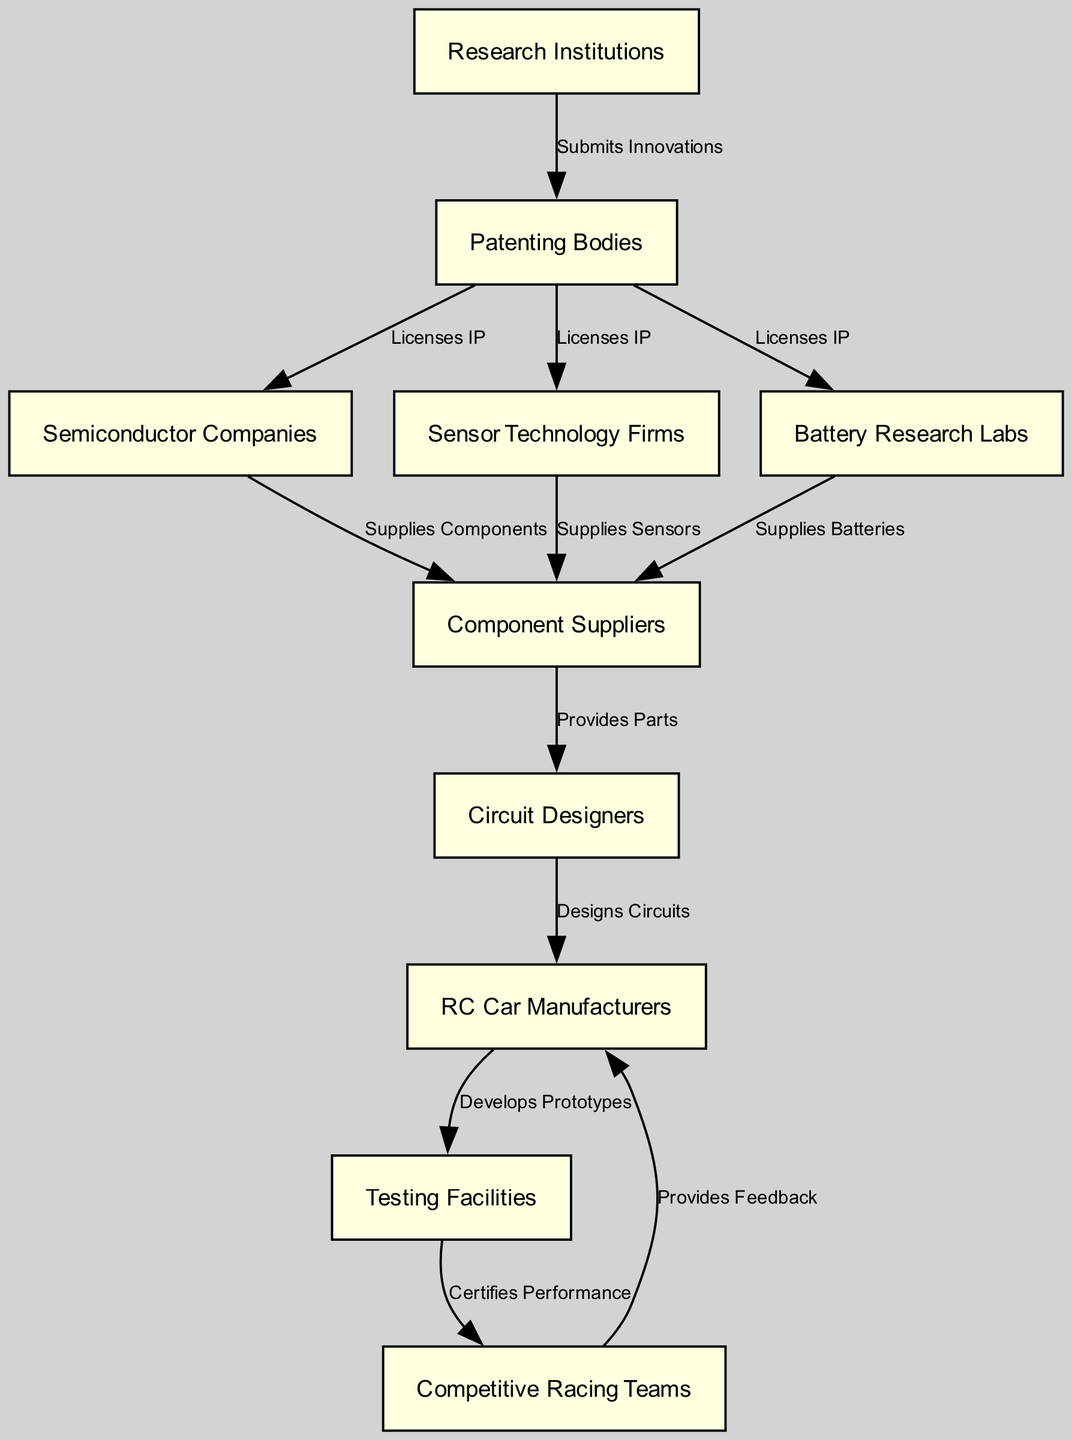What is the total number of nodes in the diagram? Counting the number of distinct entities (nodes) listed in the "nodes" section of the data, we can see there are ten entities: Research Institutions, Patenting Bodies, Semiconductor Companies, Sensor Technology Firms, Battery Research Labs, Component Suppliers, Circuit Designers, RC Car Manufacturers, Testing Facilities, and Competitive Racing Teams.
Answer: 10 Which node submits innovations? The edge pointing from "Research Institutions" to "Patenting Bodies" labeled "Submits Innovations" indicates that the Research Institutions are responsible for submitting innovations.
Answer: Research Institutions Who supplies batteries? The edge that goes from "Battery Research Labs" to "Component Suppliers" labeled "Supplies Batteries" highlights that Battery Research Labs are the ones that supply batteries.
Answer: Battery Research Labs How many edges connect the Component Suppliers? By examining the edges that either originate from or lead to "Component Suppliers," we see there are three connections: one to Circuit Designers, one from Semiconductor Companies, and one from Sensor Technology Firms. This means there are three edges associated with Component Suppliers.
Answer: 3 What is the relationship between Racing Teams and RC Manufacturers? The edge that connects "Racing Teams" to "RC Car Manufacturers" labeled "Provides Feedback" shows the interaction between them, indicating that Racing Teams provide feedback to RC Manufacturers.
Answer: Provides Feedback Which node certifies performance? The edge from "Testing Facilities" to "Racing Teams" labeled "Certifies Performance" indicates that Testing Facilities are the ones responsible for certifying the performance of the RC cars.
Answer: Testing Facilities Who designs circuits? The edge going from "Circuit Designers" to "RC Car Manufacturers" labeled "Designs Circuits" shows that Circuit Designers are responsible for designing the circuits for RC Cars.
Answer: Circuit Designers Which group licenses intellectual property? The edges from "Patenting Bodies" to the various nodes, including Semiconductor Companies, Sensor Technology Firms, and Battery Research Labs, all labeled "Licenses IP," indicate that Patenting Bodies are the group that licenses intellectual property.
Answer: Patenting Bodies From which node do component suppliers get their parts? The edge that links "Component Suppliers" to "Circuit Designers" labeled "Provides Parts" indicates that Circuit Designers obtain their parts from Component Suppliers.
Answer: Component Suppliers 